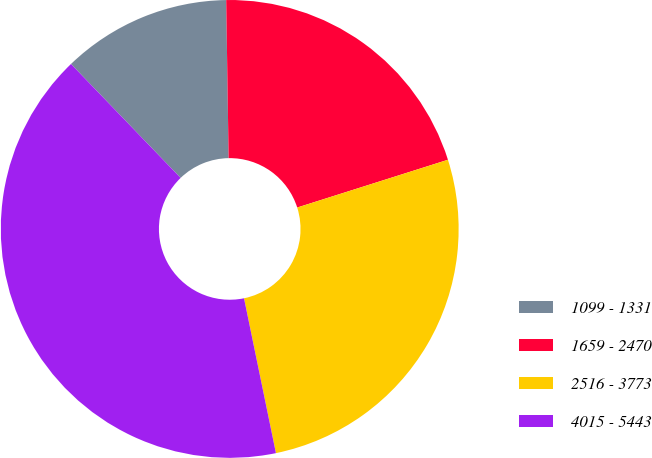<chart> <loc_0><loc_0><loc_500><loc_500><pie_chart><fcel>1099 - 1331<fcel>1659 - 2470<fcel>2516 - 3773<fcel>4015 - 5443<nl><fcel>11.95%<fcel>20.36%<fcel>26.65%<fcel>41.04%<nl></chart> 